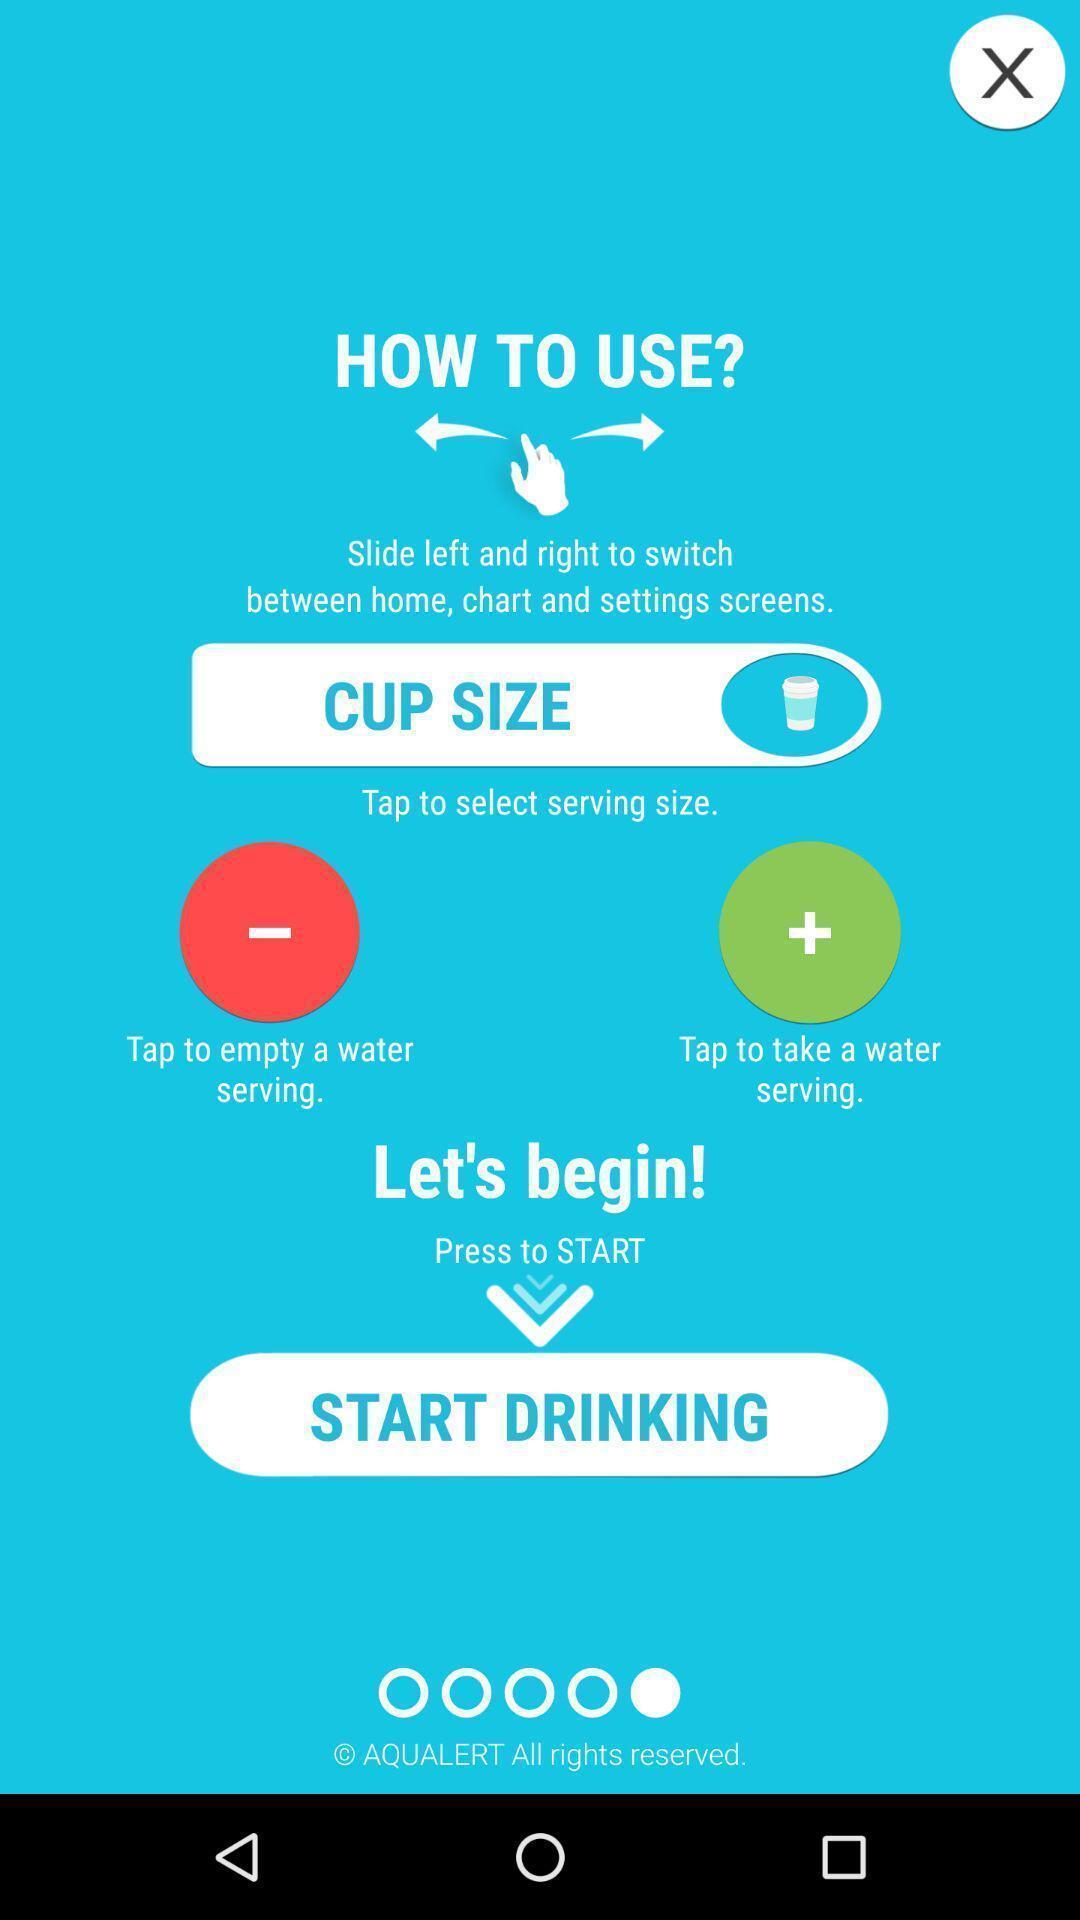Describe this image in words. Welcome page of a water drinking app. 